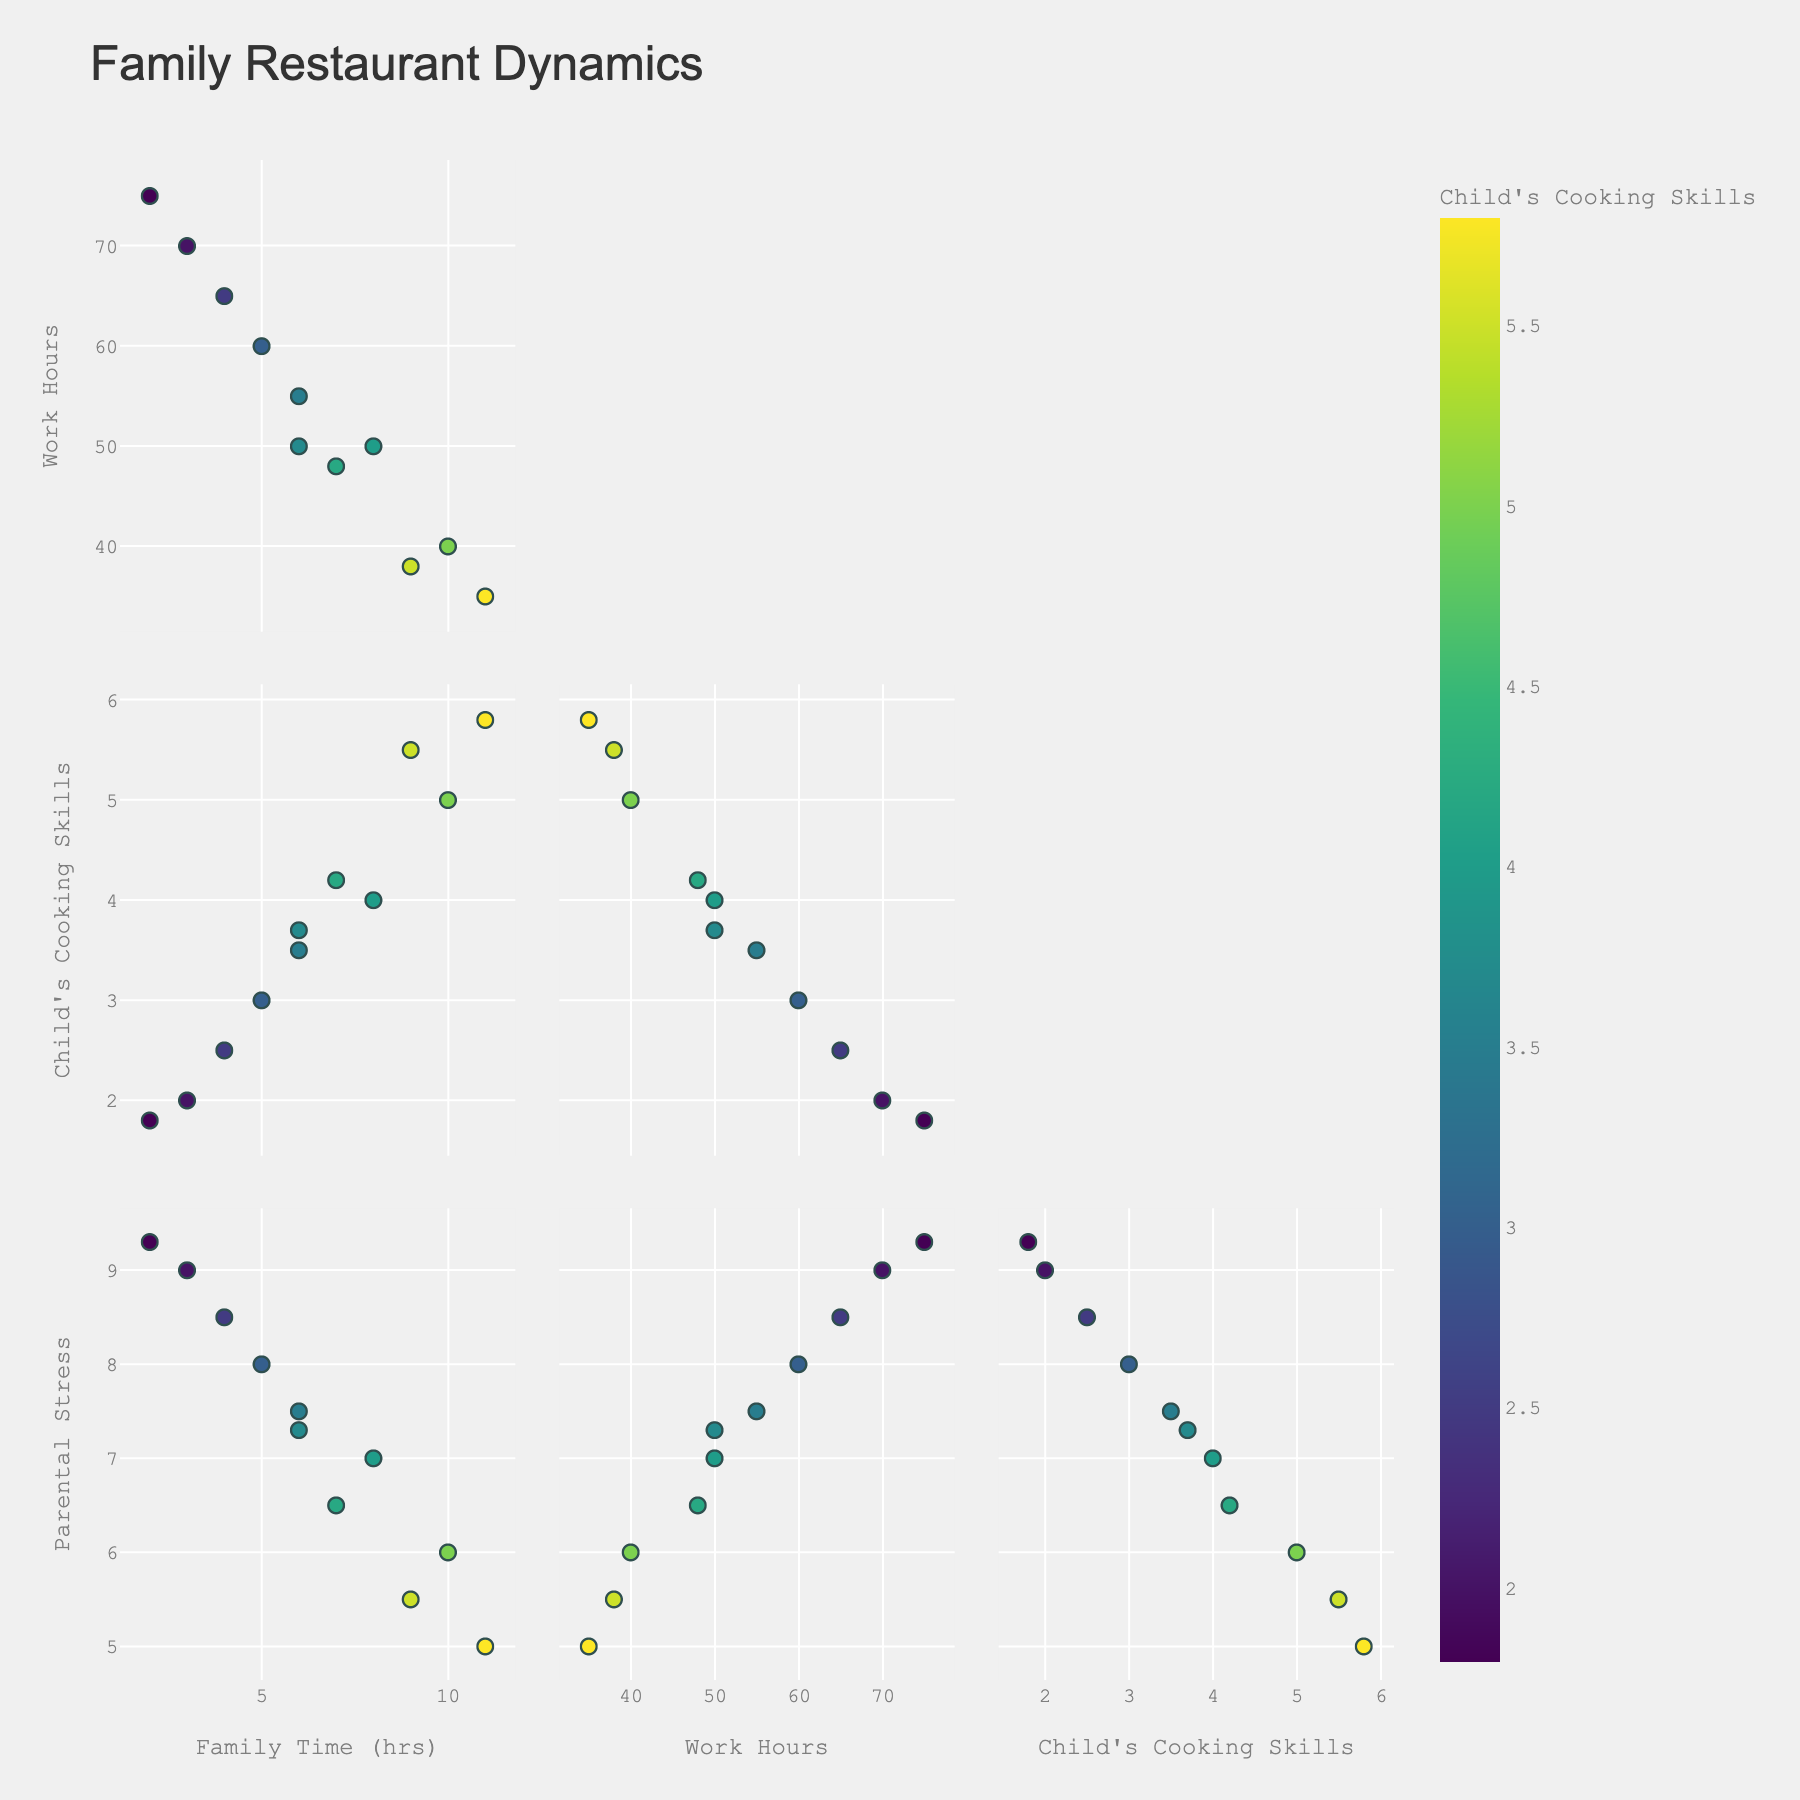What is the title of the plot? The title of the plot is displayed prominently at the top of the figure.
Answer: Family Restaurant Dynamics How many dimensions are shown in the scatter plot matrix? The scatter plot matrix displays data across multiple dimensions, each representing a different variable. Count the number of unique axes or variables.
Answer: 4 What color scale is used to represent the child's cooking skills in the figure? The color scale can be identified from the color bar labeled "Child's Cooking Skills" in the scatter plot matrix.
Answer: Viridis What is the relationship between weekly family time and restaurant work hours? Observe the scatter plots intersecting between 'Weekly Family Time' and 'Restaurant Work Hours' to determine if there is any visible trend or correlation.
Answer: Negative correlation Which dimension seems to have the most considerable variation? Identify the dimension with the widest range of data points or the most spread out in the scatter plots.
Answer: Restaurant Work Hours What can you infer about the child's cooking skills compared to parental stress levels? Examining the scatter plots between 'Child’s Cooking Skills' and 'Parental Stress Levels', check for any trends or patterns.
Answer: As child’s cooking skills improve, parental stress levels tend to decrease Looking at the diagonal plots, which dimension(s) have notable central concentrations? Identify the diagonal histograms where data points are densest near the center.
Answer: Child's Cooking Skills and Parental Stress Levels Is there a trend between weekly family time and the child's cooking skills? Analyze the scatter plots between 'Weekly Family Time' and 'Child’s Cooking Skills' for any visible trend or correlation.
Answer: Positive correlation Given two families with weekly family times of 6 and 11 hours, which family likely has lower parental stress levels? Compare the data points for weekly family times of 6 and 11 hours along with their associated parental stress levels in the scatter plots.
Answer: The family with 11 hours of weekly family time In general, how does the number of restaurant work hours impact the weekly family time? Look at the scatter plots between 'Restaurant Work Hours' and 'Weekly Family Time' to see the overall trend or pattern.
Answer: More work hours generally reduce weekly family time 